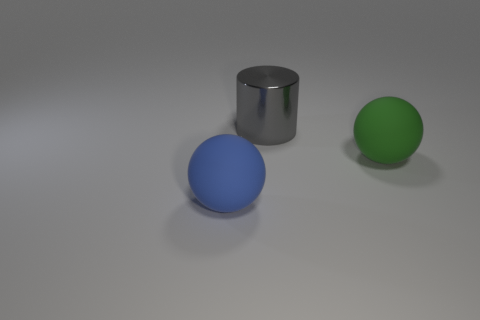Add 1 big green matte balls. How many objects exist? 4 Subtract all cylinders. How many objects are left? 2 Subtract all large shiny balls. Subtract all big gray metallic things. How many objects are left? 2 Add 3 blue matte spheres. How many blue matte spheres are left? 4 Add 2 green matte spheres. How many green matte spheres exist? 3 Subtract 0 red blocks. How many objects are left? 3 